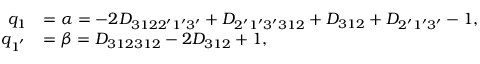<formula> <loc_0><loc_0><loc_500><loc_500>\begin{array} { r l } { q _ { 1 } } & { = \alpha = - 2 { D _ { 3 1 2 2 ^ { \prime } 1 ^ { \prime } 3 ^ { \prime } } } + { D _ { 2 ^ { \prime } 1 ^ { \prime } 3 ^ { \prime } 3 1 2 } } + { D _ { 3 1 2 } } + { D _ { 2 ^ { \prime } 1 ^ { \prime } 3 ^ { \prime } } } - 1 , } \\ { q _ { 1 ^ { ^ { \prime } } } } & { = \beta = { D _ { 3 1 2 3 1 2 } } - 2 { D _ { 3 1 2 } } + 1 , } \end{array}</formula> 